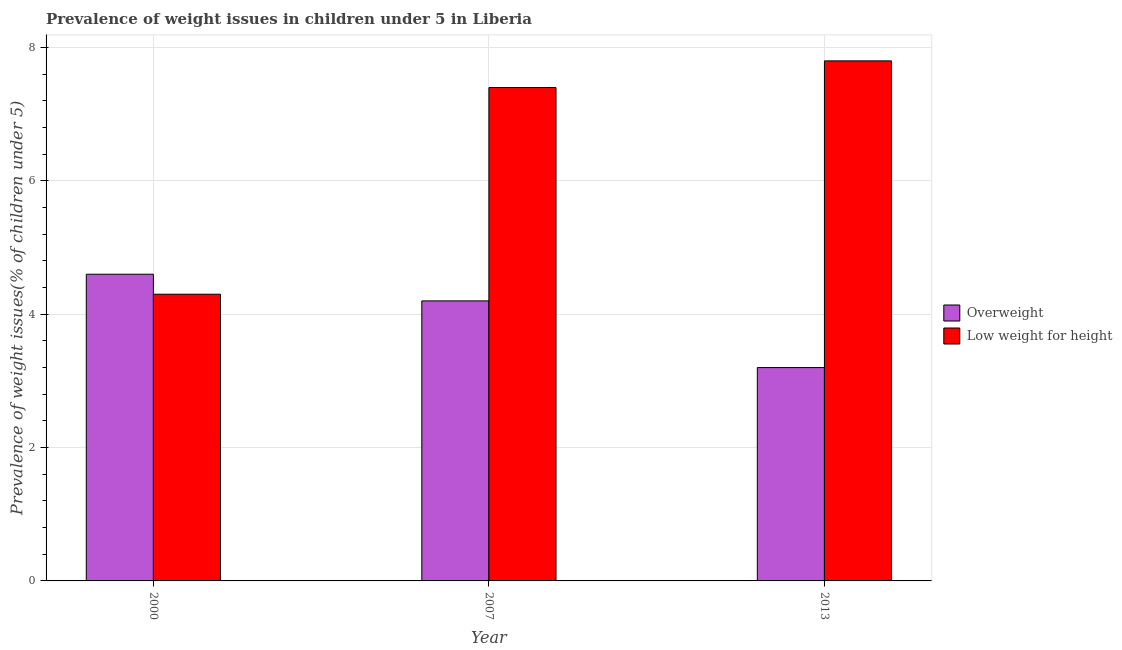How many groups of bars are there?
Make the answer very short. 3. Are the number of bars on each tick of the X-axis equal?
Offer a very short reply. Yes. In how many cases, is the number of bars for a given year not equal to the number of legend labels?
Your response must be concise. 0. What is the percentage of overweight children in 2013?
Provide a short and direct response. 3.2. Across all years, what is the maximum percentage of overweight children?
Provide a succinct answer. 4.6. Across all years, what is the minimum percentage of underweight children?
Provide a succinct answer. 4.3. In which year was the percentage of overweight children maximum?
Keep it short and to the point. 2000. What is the total percentage of underweight children in the graph?
Provide a succinct answer. 19.5. What is the difference between the percentage of underweight children in 2000 and that in 2007?
Offer a very short reply. -3.1. What is the difference between the percentage of underweight children in 2013 and the percentage of overweight children in 2007?
Provide a succinct answer. 0.4. What is the average percentage of overweight children per year?
Provide a short and direct response. 4. In the year 2007, what is the difference between the percentage of overweight children and percentage of underweight children?
Offer a terse response. 0. In how many years, is the percentage of underweight children greater than 6 %?
Ensure brevity in your answer.  2. What is the ratio of the percentage of overweight children in 2000 to that in 2007?
Provide a succinct answer. 1.1. Is the percentage of overweight children in 2000 less than that in 2007?
Give a very brief answer. No. What is the difference between the highest and the second highest percentage of overweight children?
Your answer should be compact. 0.4. What is the difference between the highest and the lowest percentage of underweight children?
Your answer should be very brief. 3.5. Is the sum of the percentage of overweight children in 2000 and 2013 greater than the maximum percentage of underweight children across all years?
Provide a short and direct response. Yes. What does the 1st bar from the left in 2007 represents?
Provide a short and direct response. Overweight. What does the 2nd bar from the right in 2013 represents?
Your answer should be very brief. Overweight. How many bars are there?
Offer a terse response. 6. What is the difference between two consecutive major ticks on the Y-axis?
Keep it short and to the point. 2. Are the values on the major ticks of Y-axis written in scientific E-notation?
Offer a very short reply. No. Does the graph contain grids?
Keep it short and to the point. Yes. Where does the legend appear in the graph?
Offer a terse response. Center right. What is the title of the graph?
Give a very brief answer. Prevalence of weight issues in children under 5 in Liberia. Does "Female labor force" appear as one of the legend labels in the graph?
Give a very brief answer. No. What is the label or title of the X-axis?
Your answer should be compact. Year. What is the label or title of the Y-axis?
Keep it short and to the point. Prevalence of weight issues(% of children under 5). What is the Prevalence of weight issues(% of children under 5) in Overweight in 2000?
Offer a terse response. 4.6. What is the Prevalence of weight issues(% of children under 5) of Low weight for height in 2000?
Provide a short and direct response. 4.3. What is the Prevalence of weight issues(% of children under 5) in Overweight in 2007?
Make the answer very short. 4.2. What is the Prevalence of weight issues(% of children under 5) in Low weight for height in 2007?
Ensure brevity in your answer.  7.4. What is the Prevalence of weight issues(% of children under 5) in Overweight in 2013?
Provide a short and direct response. 3.2. What is the Prevalence of weight issues(% of children under 5) in Low weight for height in 2013?
Offer a very short reply. 7.8. Across all years, what is the maximum Prevalence of weight issues(% of children under 5) in Overweight?
Your answer should be compact. 4.6. Across all years, what is the maximum Prevalence of weight issues(% of children under 5) of Low weight for height?
Ensure brevity in your answer.  7.8. Across all years, what is the minimum Prevalence of weight issues(% of children under 5) of Overweight?
Give a very brief answer. 3.2. Across all years, what is the minimum Prevalence of weight issues(% of children under 5) of Low weight for height?
Provide a succinct answer. 4.3. What is the total Prevalence of weight issues(% of children under 5) of Overweight in the graph?
Make the answer very short. 12. What is the difference between the Prevalence of weight issues(% of children under 5) in Low weight for height in 2000 and that in 2007?
Keep it short and to the point. -3.1. What is the difference between the Prevalence of weight issues(% of children under 5) of Low weight for height in 2000 and that in 2013?
Offer a very short reply. -3.5. What is the difference between the Prevalence of weight issues(% of children under 5) in Overweight in 2007 and that in 2013?
Keep it short and to the point. 1. What is the difference between the Prevalence of weight issues(% of children under 5) in Low weight for height in 2007 and that in 2013?
Offer a very short reply. -0.4. What is the average Prevalence of weight issues(% of children under 5) of Overweight per year?
Your answer should be compact. 4. In the year 2007, what is the difference between the Prevalence of weight issues(% of children under 5) in Overweight and Prevalence of weight issues(% of children under 5) in Low weight for height?
Offer a very short reply. -3.2. What is the ratio of the Prevalence of weight issues(% of children under 5) of Overweight in 2000 to that in 2007?
Provide a short and direct response. 1.1. What is the ratio of the Prevalence of weight issues(% of children under 5) in Low weight for height in 2000 to that in 2007?
Ensure brevity in your answer.  0.58. What is the ratio of the Prevalence of weight issues(% of children under 5) of Overweight in 2000 to that in 2013?
Make the answer very short. 1.44. What is the ratio of the Prevalence of weight issues(% of children under 5) in Low weight for height in 2000 to that in 2013?
Your response must be concise. 0.55. What is the ratio of the Prevalence of weight issues(% of children under 5) of Overweight in 2007 to that in 2013?
Give a very brief answer. 1.31. What is the ratio of the Prevalence of weight issues(% of children under 5) in Low weight for height in 2007 to that in 2013?
Make the answer very short. 0.95. What is the difference between the highest and the second highest Prevalence of weight issues(% of children under 5) of Low weight for height?
Provide a succinct answer. 0.4. What is the difference between the highest and the lowest Prevalence of weight issues(% of children under 5) in Overweight?
Your response must be concise. 1.4. What is the difference between the highest and the lowest Prevalence of weight issues(% of children under 5) in Low weight for height?
Offer a terse response. 3.5. 